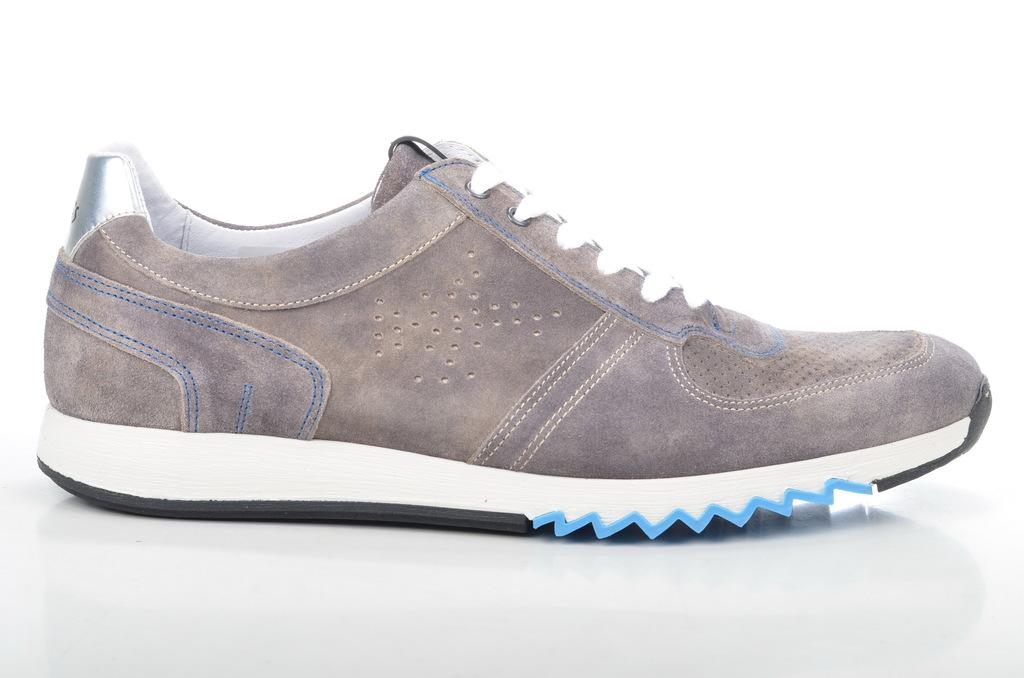What is the main subject in the center of the image? There is a shoe in the center of the image. What type of lead can be seen in the cemetery near the wall in the image? There is no lead, cemetery, or wall present in the image; it only features a shoe in the center. 